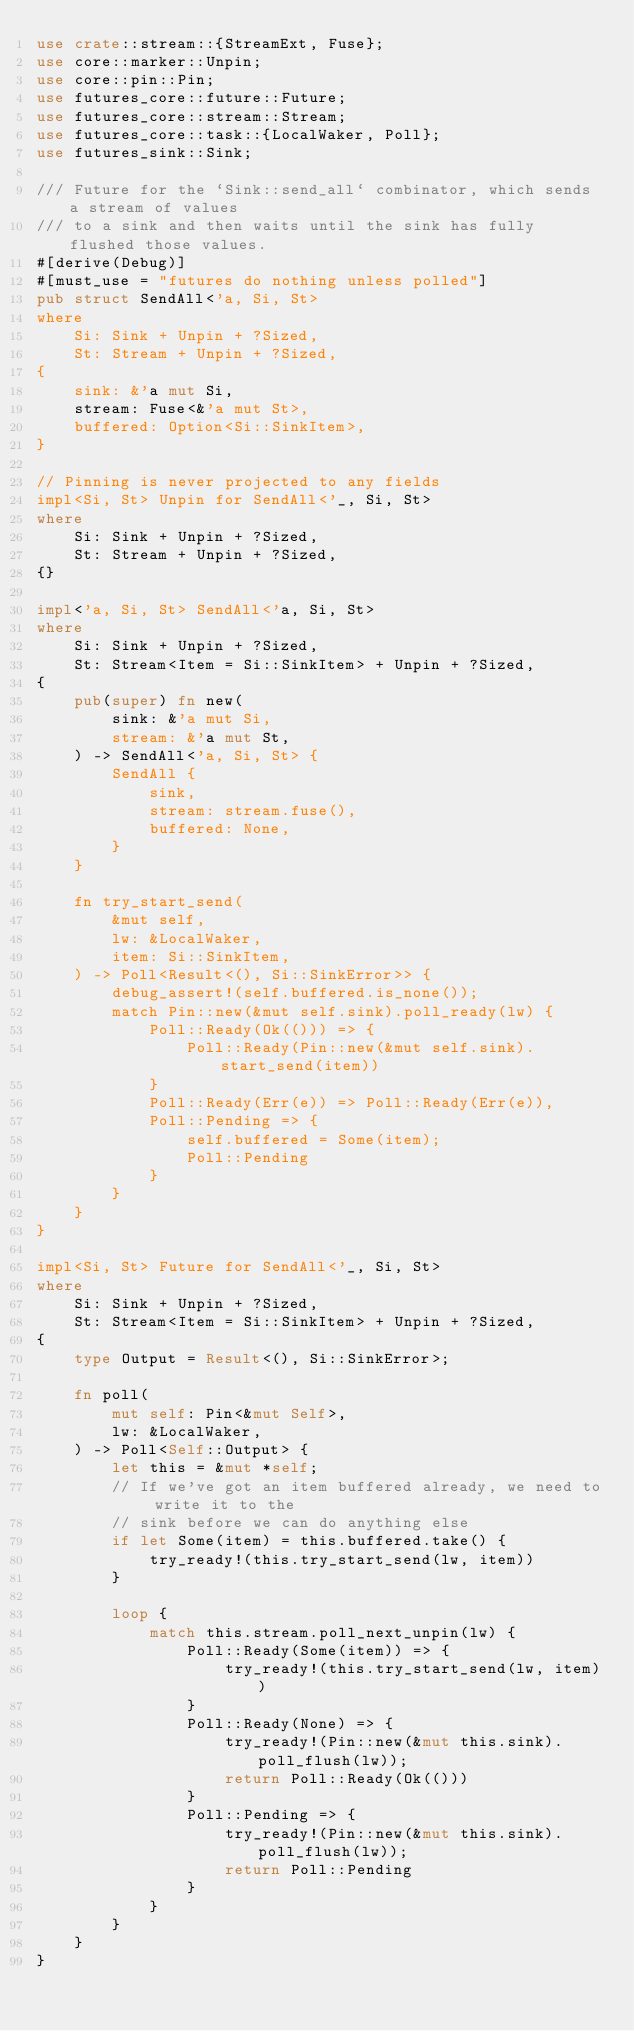Convert code to text. <code><loc_0><loc_0><loc_500><loc_500><_Rust_>use crate::stream::{StreamExt, Fuse};
use core::marker::Unpin;
use core::pin::Pin;
use futures_core::future::Future;
use futures_core::stream::Stream;
use futures_core::task::{LocalWaker, Poll};
use futures_sink::Sink;

/// Future for the `Sink::send_all` combinator, which sends a stream of values
/// to a sink and then waits until the sink has fully flushed those values.
#[derive(Debug)]
#[must_use = "futures do nothing unless polled"]
pub struct SendAll<'a, Si, St>
where
    Si: Sink + Unpin + ?Sized,
    St: Stream + Unpin + ?Sized,
{
    sink: &'a mut Si,
    stream: Fuse<&'a mut St>,
    buffered: Option<Si::SinkItem>,
}

// Pinning is never projected to any fields
impl<Si, St> Unpin for SendAll<'_, Si, St>
where
    Si: Sink + Unpin + ?Sized,
    St: Stream + Unpin + ?Sized,
{}

impl<'a, Si, St> SendAll<'a, Si, St>
where
    Si: Sink + Unpin + ?Sized,
    St: Stream<Item = Si::SinkItem> + Unpin + ?Sized,
{
    pub(super) fn new(
        sink: &'a mut Si,
        stream: &'a mut St,
    ) -> SendAll<'a, Si, St> {
        SendAll {
            sink,
            stream: stream.fuse(),
            buffered: None,
        }
    }

    fn try_start_send(
        &mut self,
        lw: &LocalWaker,
        item: Si::SinkItem,
    ) -> Poll<Result<(), Si::SinkError>> {
        debug_assert!(self.buffered.is_none());
        match Pin::new(&mut self.sink).poll_ready(lw) {
            Poll::Ready(Ok(())) => {
                Poll::Ready(Pin::new(&mut self.sink).start_send(item))
            }
            Poll::Ready(Err(e)) => Poll::Ready(Err(e)),
            Poll::Pending => {
                self.buffered = Some(item);
                Poll::Pending
            }
        }
    }
}

impl<Si, St> Future for SendAll<'_, Si, St>
where
    Si: Sink + Unpin + ?Sized,
    St: Stream<Item = Si::SinkItem> + Unpin + ?Sized,
{
    type Output = Result<(), Si::SinkError>;

    fn poll(
        mut self: Pin<&mut Self>,
        lw: &LocalWaker,
    ) -> Poll<Self::Output> {
        let this = &mut *self;
        // If we've got an item buffered already, we need to write it to the
        // sink before we can do anything else
        if let Some(item) = this.buffered.take() {
            try_ready!(this.try_start_send(lw, item))
        }

        loop {
            match this.stream.poll_next_unpin(lw) {
                Poll::Ready(Some(item)) => {
                    try_ready!(this.try_start_send(lw, item))
                }
                Poll::Ready(None) => {
                    try_ready!(Pin::new(&mut this.sink).poll_flush(lw));
                    return Poll::Ready(Ok(()))
                }
                Poll::Pending => {
                    try_ready!(Pin::new(&mut this.sink).poll_flush(lw));
                    return Poll::Pending
                }
            }
        }
    }
}
</code> 